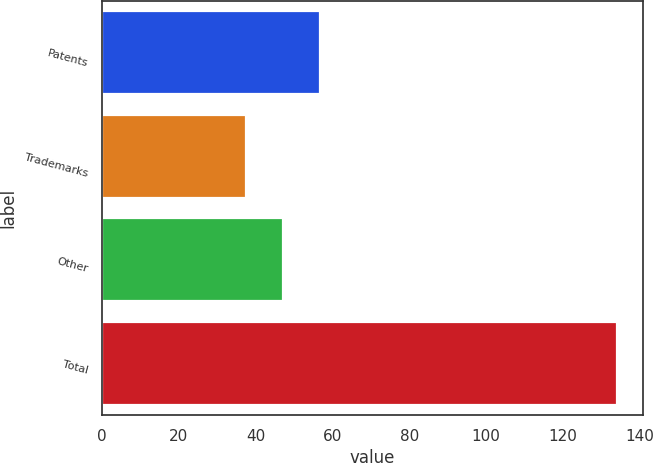<chart> <loc_0><loc_0><loc_500><loc_500><bar_chart><fcel>Patents<fcel>Trademarks<fcel>Other<fcel>Total<nl><fcel>56.82<fcel>37.5<fcel>47.16<fcel>134.1<nl></chart> 